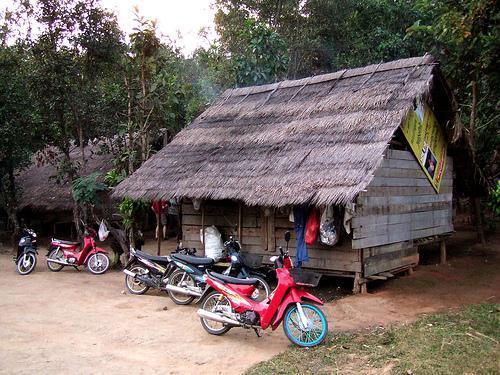How many mopeds are there?
Give a very brief answer. 5. How many red mopeds are there?
Give a very brief answer. 2. How many houses are there?
Give a very brief answer. 1. 